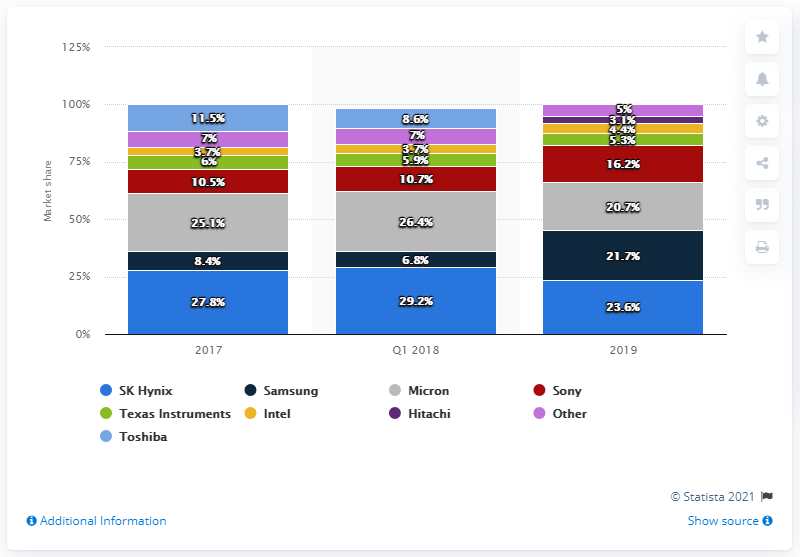Identify some key points in this picture. According to data from 2019, Samsung held a significant percentage of the global NAND and DRAM storage market. Specifically, they held 21.7% of the market. In 2017, Samsung's market share was 8.4%. The difference in Micron and Sony's maximum and minimum shares over the years is 34.8%. According to a 2019 report, SK Hynix was the leading storage manufacturer in that year. In 2019, SK Hynix accounted for approximately 23.6% of the global NAND and DRAM storage systems market. 